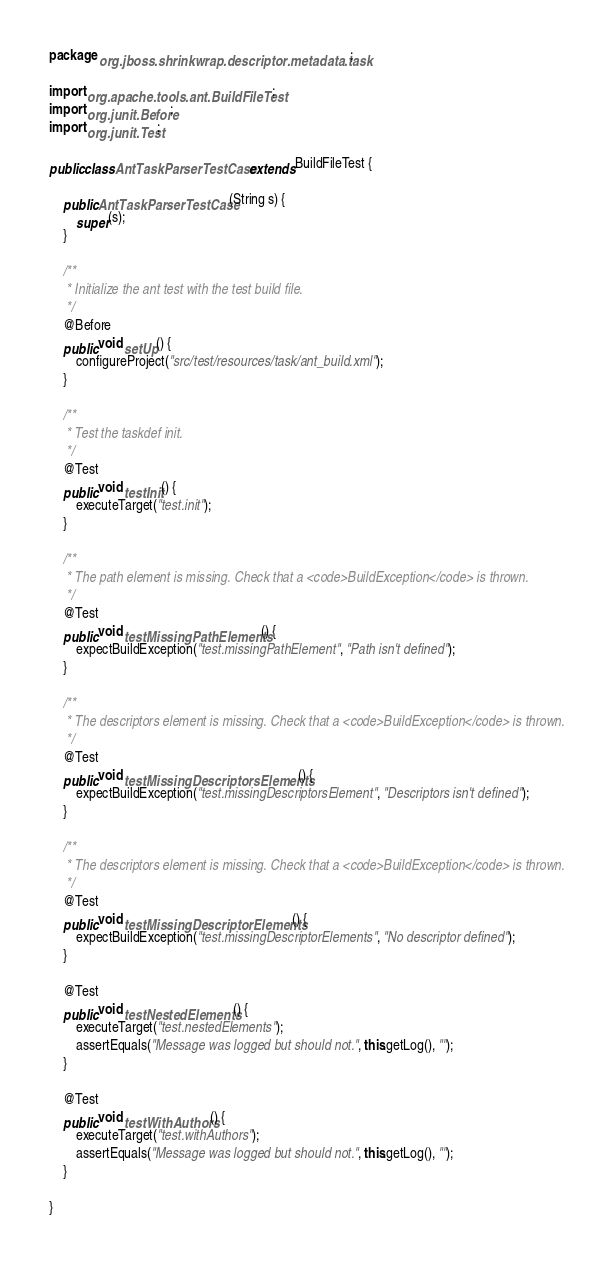<code> <loc_0><loc_0><loc_500><loc_500><_Java_>package org.jboss.shrinkwrap.descriptor.metadata.task;

import org.apache.tools.ant.BuildFileTest;
import org.junit.Before;
import org.junit.Test;

public class AntTaskParserTestCase extends BuildFileTest {

    public AntTaskParserTestCase(String s) {
        super(s);
    }

    /**
     * Initialize the ant test with the test build file.
     */
    @Before
    public void setUp() {
        configureProject("src/test/resources/task/ant_build.xml");
    }

    /**
     * Test the taskdef init.
     */
    @Test
    public void testInit() {
        executeTarget("test.init");
    }

    /**
     * The path element is missing. Check that a <code>BuildException</code> is thrown.
     */
    @Test
    public void testMissingPathElements() {
        expectBuildException("test.missingPathElement", "Path isn't defined");
    }    

    /**
     * The descriptors element is missing. Check that a <code>BuildException</code> is thrown.
     */
    @Test
    public void testMissingDescriptorsElements() {
        expectBuildException("test.missingDescriptorsElement", "Descriptors isn't defined");
    }

    /**
     * The descriptors element is missing. Check that a <code>BuildException</code> is thrown.
     */
    @Test
    public void testMissingDescriptorElements() {
        expectBuildException("test.missingDescriptorElements", "No descriptor defined");
    }
    
    @Test
    public void testNestedElements() {
        executeTarget("test.nestedElements");
        assertEquals("Message was logged but should not.", this.getLog(), "");
    }
    
    @Test
    public void testWithAuthors() {
        executeTarget("test.withAuthors");
        assertEquals("Message was logged but should not.", this.getLog(), "");
    }
   
}
</code> 